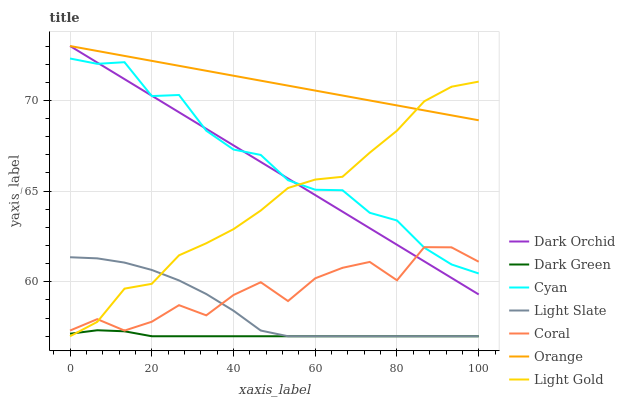Does Coral have the minimum area under the curve?
Answer yes or no. No. Does Coral have the maximum area under the curve?
Answer yes or no. No. Is Coral the smoothest?
Answer yes or no. No. Is Dark Orchid the roughest?
Answer yes or no. No. Does Coral have the lowest value?
Answer yes or no. No. Does Coral have the highest value?
Answer yes or no. No. Is Dark Green less than Dark Orchid?
Answer yes or no. Yes. Is Dark Orchid greater than Light Slate?
Answer yes or no. Yes. Does Dark Green intersect Dark Orchid?
Answer yes or no. No. 